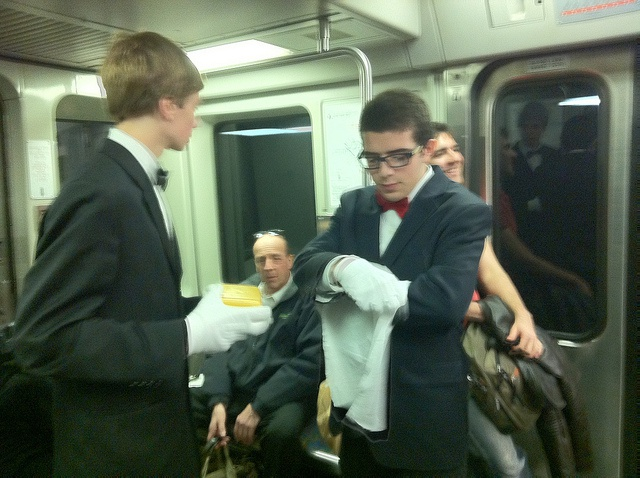Describe the objects in this image and their specific colors. I can see people in gray, black, and beige tones, people in gray, black, purple, and turquoise tones, people in gray, black, teal, and darkgreen tones, people in gray, tan, and black tones, and people in gray, black, and purple tones in this image. 